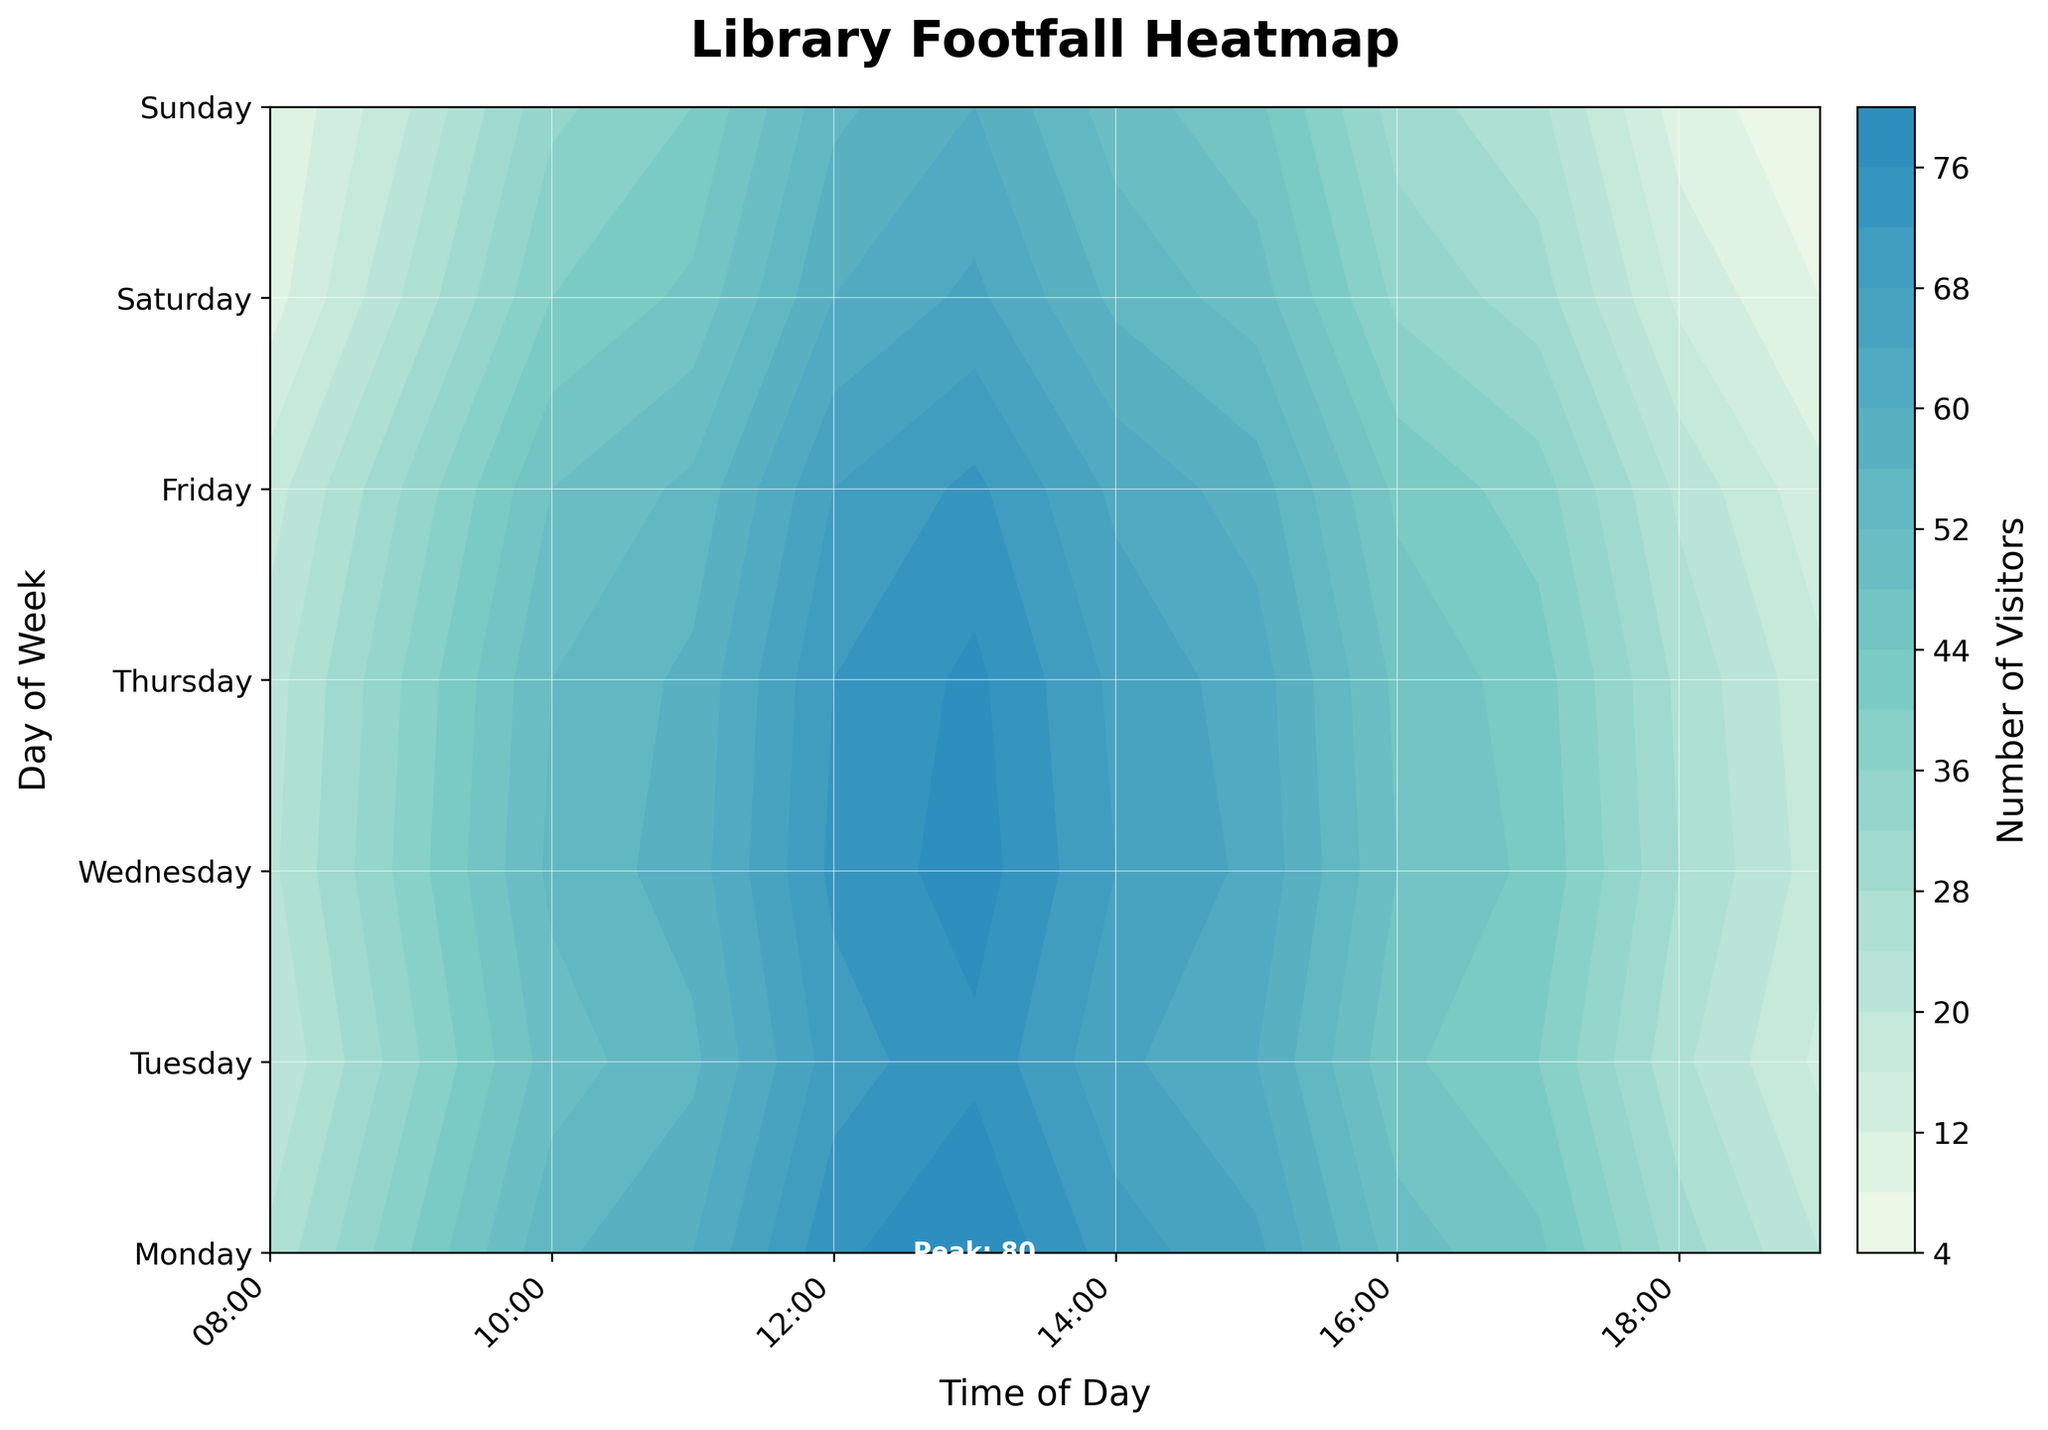What is the title of the plot? The title is located at the top of the plot, centered and in bold.
Answer: Library Footfall Heatmap Which day has the highest number of visitors at 1 PM? By observing the y-axis labeled 'Day of Week' and the x-axis labeled 'Time of Day,' you can see that 1 PM corresponds to the highest number of visitors on Monday.
Answer: Monday At what time does visitor footfall peak on Saturday? By analyzing the contours for Saturday along the x-axis, you can see the peak visitor volume is at 1 PM.
Answer: 1 PM Is the visitor count generally higher in the morning or afternoon during weekdays? Compare the contour levels from 8 AM to 12 PM (morning) with those from 12 PM to 6 PM (afternoon) from Monday to Friday. The afternoon shows generally higher visitor counts.
Answer: Afternoon What are the colors used in the colormap to represent different levels of footfall? The color gradient ranges from light green, medium turquoise, to dark blue. These colors represent increasing levels of visitors.
Answer: Light green, medium turquoise, dark blue Which time slot and day has the lowest footfall throughout the week? Locate the point with the lightest color in the contour plot. It appears at 7 PM on Sunday.
Answer: 7 PM on Sunday How does the footfall on Friday at 10 AM compare to that on Tuesday at 3 PM? By locating these specific time slots and comparing the contour colors, you'll see the Friday 10 AM slot has a higher number of visitors compared to Tuesday at 3 PM.
Answer: Friday at 10 AM is higher What is the average number of visitors on Wednesday between 12 PM and 2 PM? Check the visitors count at 12 PM, 1 PM, and 2 PM for Wednesday. The average is (73 + 78 + 68)/3 = 73.
Answer: 73 Does the contour plot indicate any specific hours of peak footfall consistently across most days? By observing the contours at different times and days, 1 PM appears to be a consistent peak time across most days.
Answer: 1 PM What visual elements make it easier to read the heatmap and find the peak visitor times? The title, axis labels, custom ticks, color bar, and annotated peak hours all make the heatmap easier to read.
Answer: Title, axis labels, custom ticks, color bar, annotated peak hours 